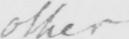What is written in this line of handwriting? other 